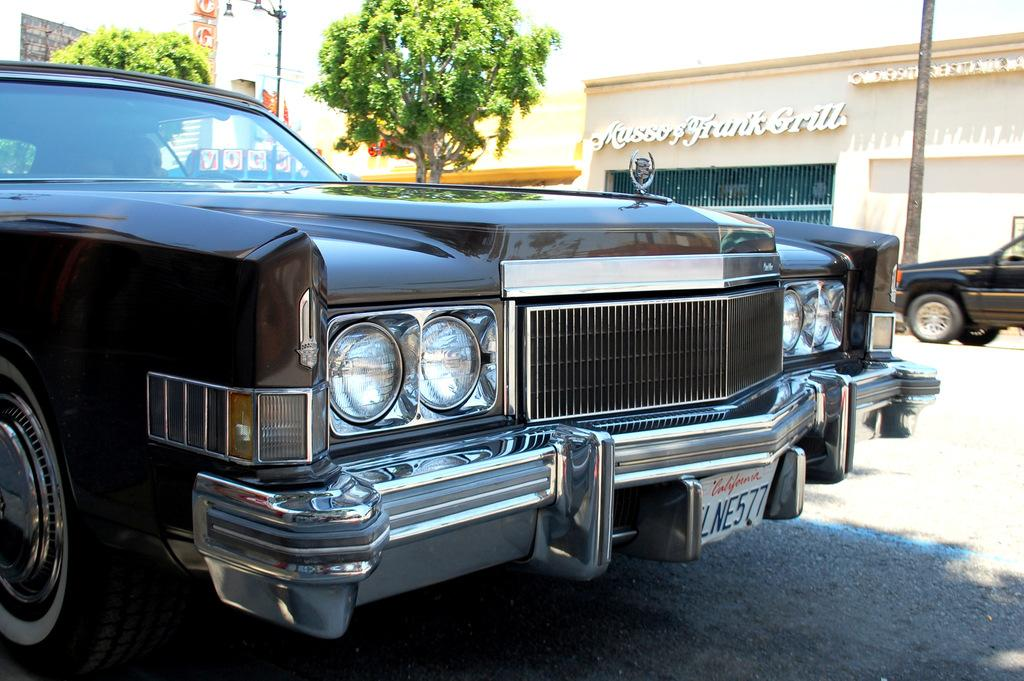What is parked on the road in the image? There is a vehicle parked on the road in the image. What can be seen in the background of the image? There are buildings, trees, and a pole in the background of the image. Are there any other vehicles visible in the image? Yes, there is another vehicle on the road in the background of the image. What type of oven is being used by the doctor in the image? There is no oven or doctor present in the image. What is the vehicle learning in the image? Vehicles do not learn; they are inanimate objects. 